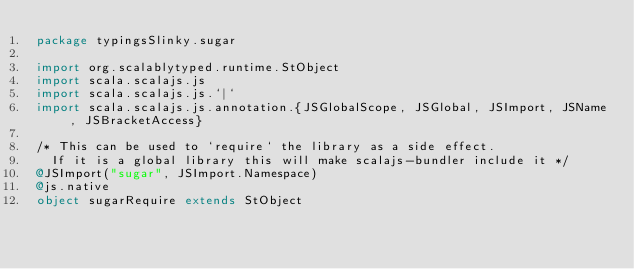<code> <loc_0><loc_0><loc_500><loc_500><_Scala_>package typingsSlinky.sugar

import org.scalablytyped.runtime.StObject
import scala.scalajs.js
import scala.scalajs.js.`|`
import scala.scalajs.js.annotation.{JSGlobalScope, JSGlobal, JSImport, JSName, JSBracketAccess}

/* This can be used to `require` the library as a side effect.
  If it is a global library this will make scalajs-bundler include it */
@JSImport("sugar", JSImport.Namespace)
@js.native
object sugarRequire extends StObject
</code> 